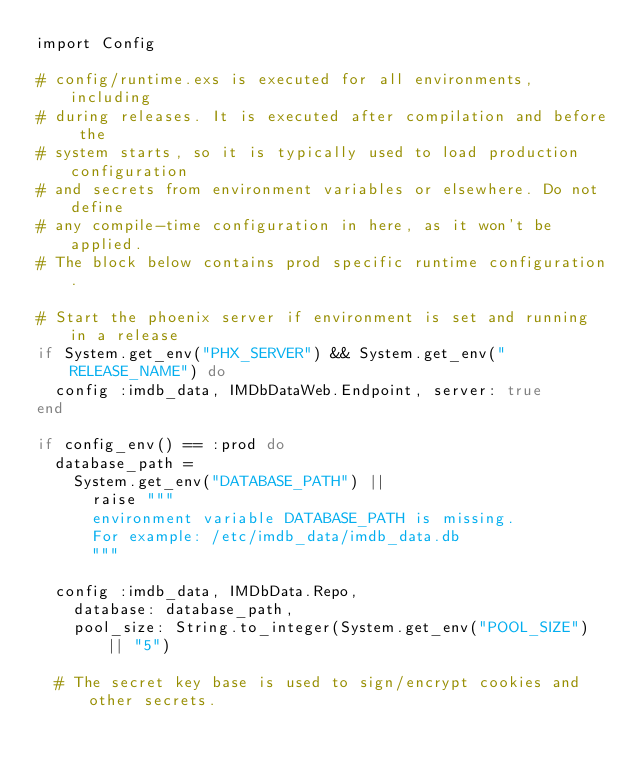<code> <loc_0><loc_0><loc_500><loc_500><_Elixir_>import Config

# config/runtime.exs is executed for all environments, including
# during releases. It is executed after compilation and before the
# system starts, so it is typically used to load production configuration
# and secrets from environment variables or elsewhere. Do not define
# any compile-time configuration in here, as it won't be applied.
# The block below contains prod specific runtime configuration.

# Start the phoenix server if environment is set and running in a release
if System.get_env("PHX_SERVER") && System.get_env("RELEASE_NAME") do
  config :imdb_data, IMDbDataWeb.Endpoint, server: true
end

if config_env() == :prod do
  database_path =
    System.get_env("DATABASE_PATH") ||
      raise """
      environment variable DATABASE_PATH is missing.
      For example: /etc/imdb_data/imdb_data.db
      """

  config :imdb_data, IMDbData.Repo,
    database: database_path,
    pool_size: String.to_integer(System.get_env("POOL_SIZE") || "5")

  # The secret key base is used to sign/encrypt cookies and other secrets.</code> 